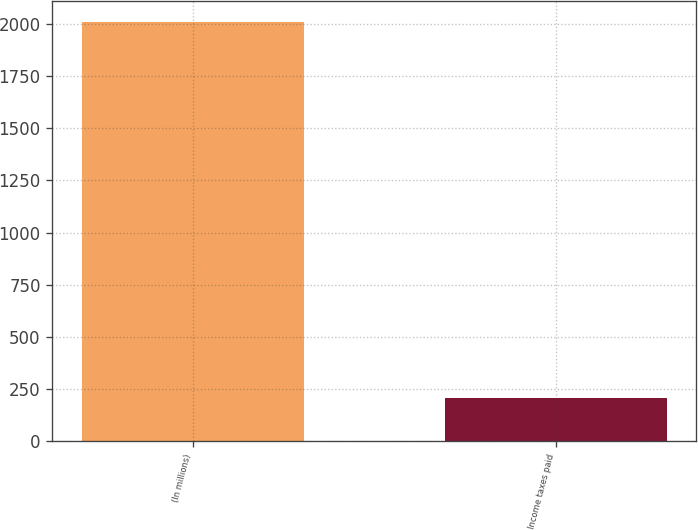Convert chart. <chart><loc_0><loc_0><loc_500><loc_500><bar_chart><fcel>(In millions)<fcel>Income taxes paid<nl><fcel>2010<fcel>209<nl></chart> 